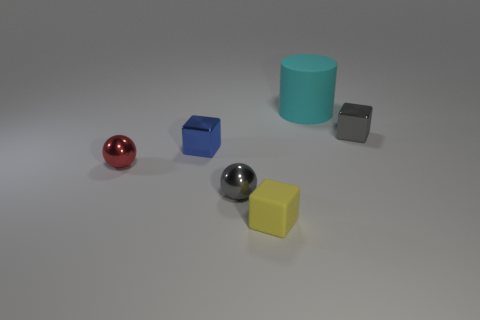Subtract all small blue cubes. How many cubes are left? 2 Add 2 blue cubes. How many objects exist? 8 Subtract 1 blocks. How many blocks are left? 2 Subtract all spheres. How many objects are left? 4 Subtract all yellow objects. Subtract all matte blocks. How many objects are left? 4 Add 3 tiny blue objects. How many tiny blue objects are left? 4 Add 6 large green rubber spheres. How many large green rubber spheres exist? 6 Subtract 0 red blocks. How many objects are left? 6 Subtract all red balls. Subtract all purple blocks. How many balls are left? 1 